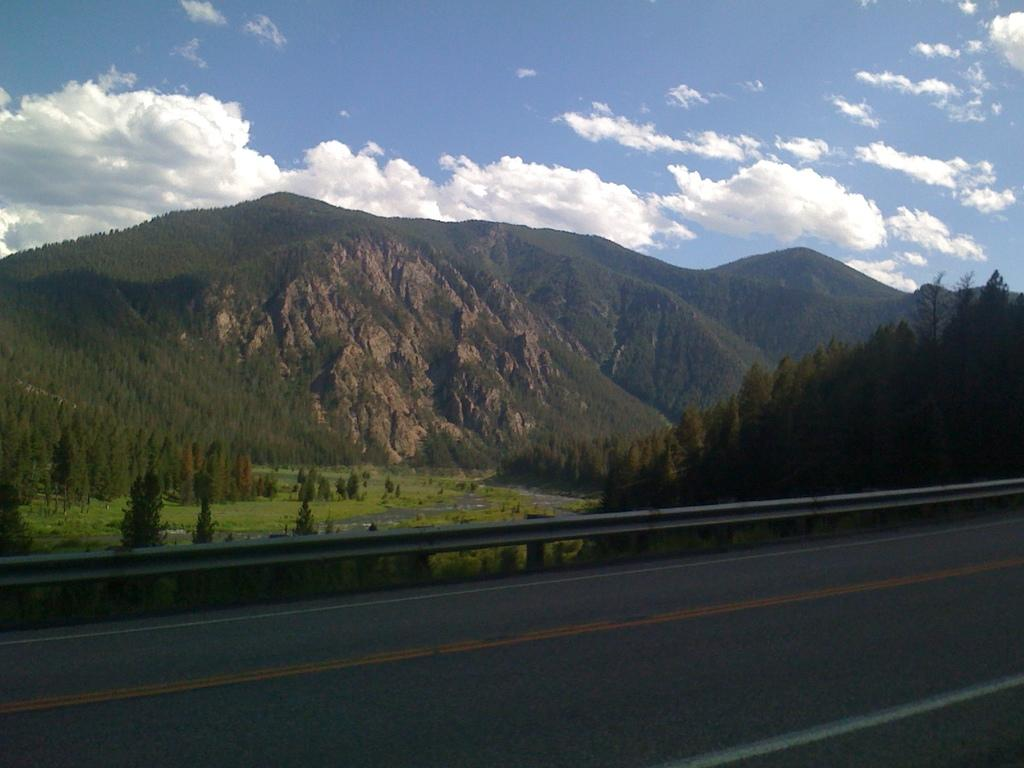What type of surface can be seen in the image? There is a road in the image. What type of vegetation is present in the image? There is grass and trees in the image. What type of terrain can be seen in the image? There are hills in the image. What is visible in the background of the image? The sky is blue in the background, and there are clouds in the sky. Can you see a protest happening on the road in the image? There is no protest visible in the image; it only shows a road, grass, trees, hills, and a blue sky with clouds. Is there a turkey walking on the grass in the image? There is no turkey present in the image; it only shows a road, grass, trees, hills, and a blue sky with clouds. 